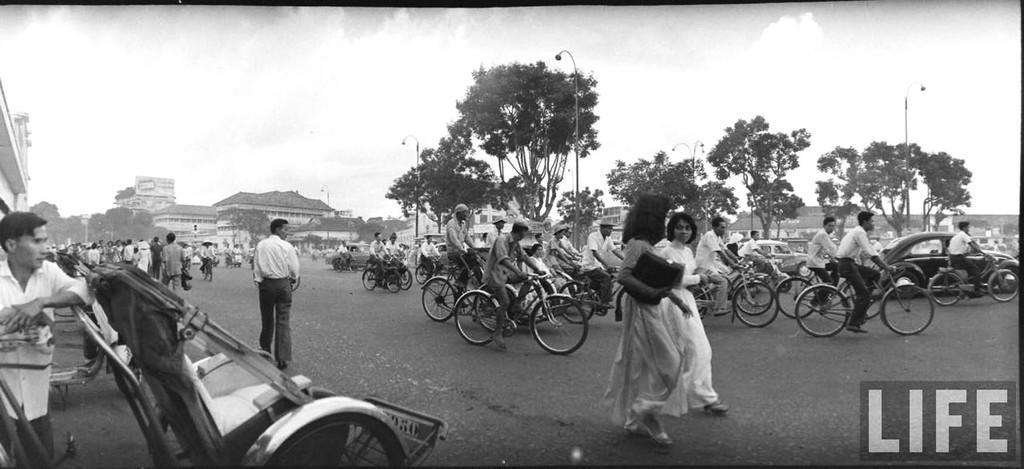In one or two sentences, can you explain what this image depicts? It seems to be the image is outside of the city. In the image there are group of people sitting on bicycle and riding it and few people are standing and walking, on left side we can see a rickshaw. On right there are some street lights in background we can see some building on top there is a sky. 